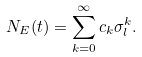Convert formula to latex. <formula><loc_0><loc_0><loc_500><loc_500>N _ { E } ( t ) = \sum _ { k = 0 } ^ { \infty } c _ { k } \sigma _ { l } ^ { k } .</formula> 